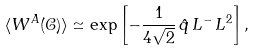<formula> <loc_0><loc_0><loc_500><loc_500>\langle W ^ { A } ( \mathcal { C } ) \rangle \simeq \exp \left [ - \frac { 1 } { 4 \sqrt { 2 } } \, \hat { q } \, L ^ { - } \, L ^ { 2 } \right ] ,</formula> 